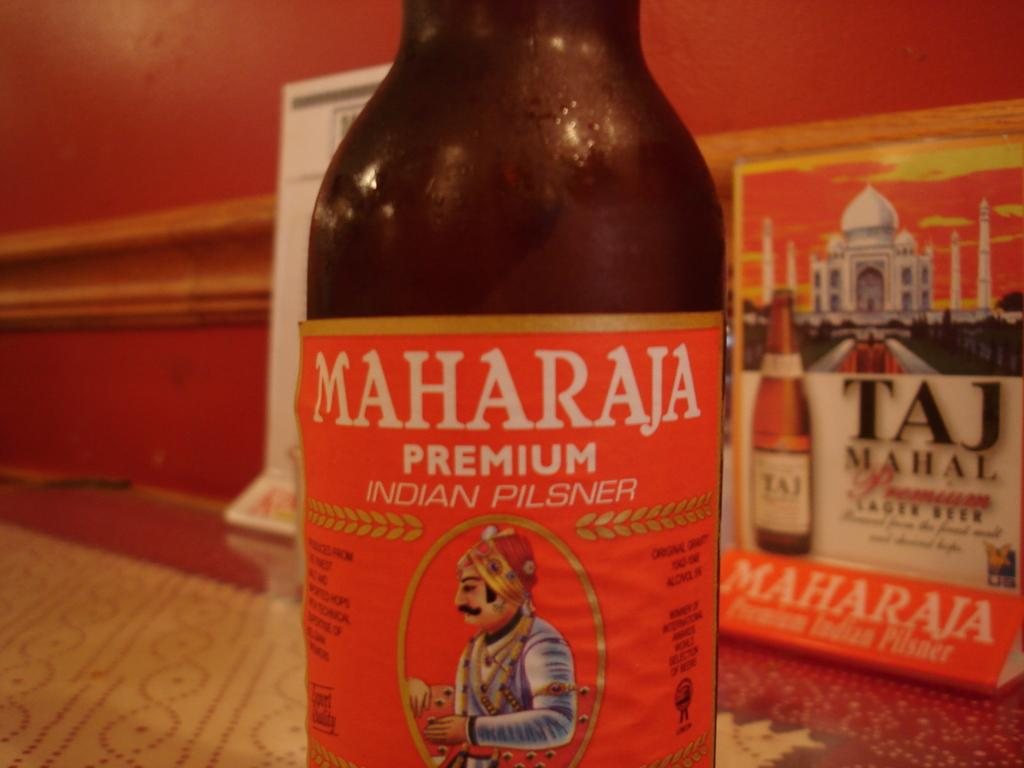<image>
Provide a brief description of the given image. The bottle of beer shown is premium and from India. 